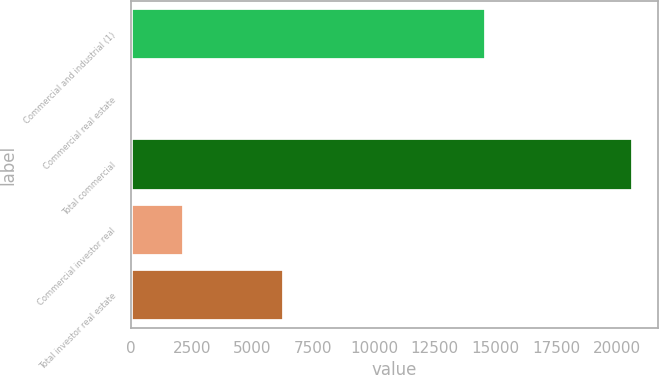Convert chart to OTSL. <chart><loc_0><loc_0><loc_500><loc_500><bar_chart><fcel>Commercial and industrial (1)<fcel>Commercial real estate<fcel>Total commercial<fcel>Commercial investor real<fcel>Total investor real estate<nl><fcel>14613<fcel>126<fcel>20652<fcel>2178.6<fcel>6305.6<nl></chart> 